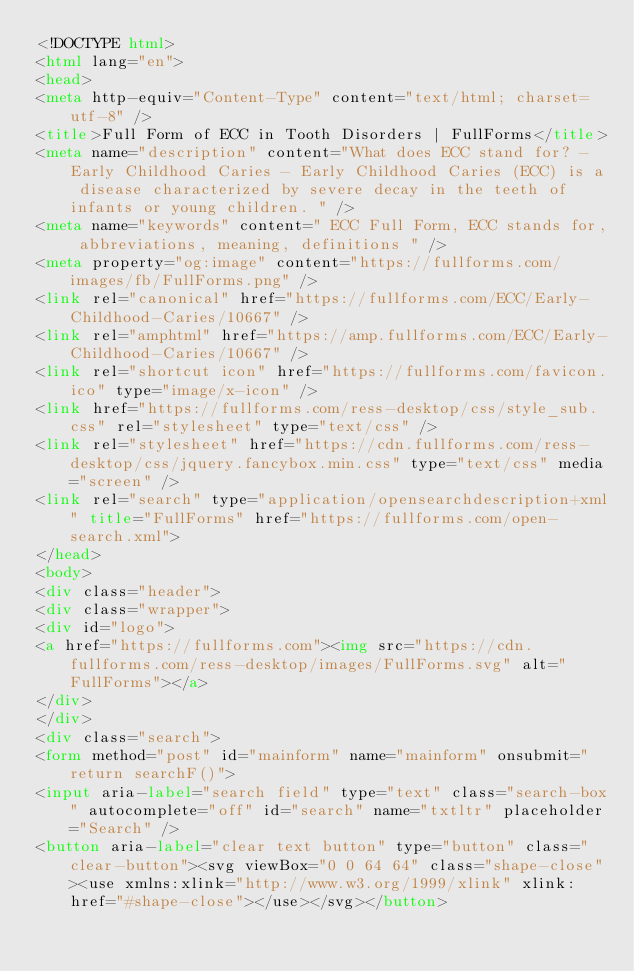<code> <loc_0><loc_0><loc_500><loc_500><_HTML_><!DOCTYPE html>
<html lang="en">
<head>
<meta http-equiv="Content-Type" content="text/html; charset=utf-8" />
<title>Full Form of ECC in Tooth Disorders | FullForms</title>
<meta name="description" content="What does ECC stand for? - Early Childhood Caries - Early Childhood Caries (ECC) is a disease characterized by severe decay in the teeth of infants or young children. " />
<meta name="keywords" content=" ECC Full Form, ECC stands for, abbreviations, meaning, definitions " />
<meta property="og:image" content="https://fullforms.com/images/fb/FullForms.png" />
<link rel="canonical" href="https://fullforms.com/ECC/Early-Childhood-Caries/10667" />
<link rel="amphtml" href="https://amp.fullforms.com/ECC/Early-Childhood-Caries/10667" />
<link rel="shortcut icon" href="https://fullforms.com/favicon.ico" type="image/x-icon" />
<link href="https://fullforms.com/ress-desktop/css/style_sub.css" rel="stylesheet" type="text/css" />
<link rel="stylesheet" href="https://cdn.fullforms.com/ress-desktop/css/jquery.fancybox.min.css" type="text/css" media="screen" />
<link rel="search" type="application/opensearchdescription+xml" title="FullForms" href="https://fullforms.com/open-search.xml">
</head>
<body>
<div class="header">
<div class="wrapper">
<div id="logo">
<a href="https://fullforms.com"><img src="https://cdn.fullforms.com/ress-desktop/images/FullForms.svg" alt="FullForms"></a>
</div>
</div>
<div class="search">
<form method="post" id="mainform" name="mainform" onsubmit="return searchF()">
<input aria-label="search field" type="text" class="search-box" autocomplete="off" id="search" name="txtltr" placeholder="Search" />
<button aria-label="clear text button" type="button" class="clear-button"><svg viewBox="0 0 64 64" class="shape-close"><use xmlns:xlink="http://www.w3.org/1999/xlink" xlink:href="#shape-close"></use></svg></button></code> 